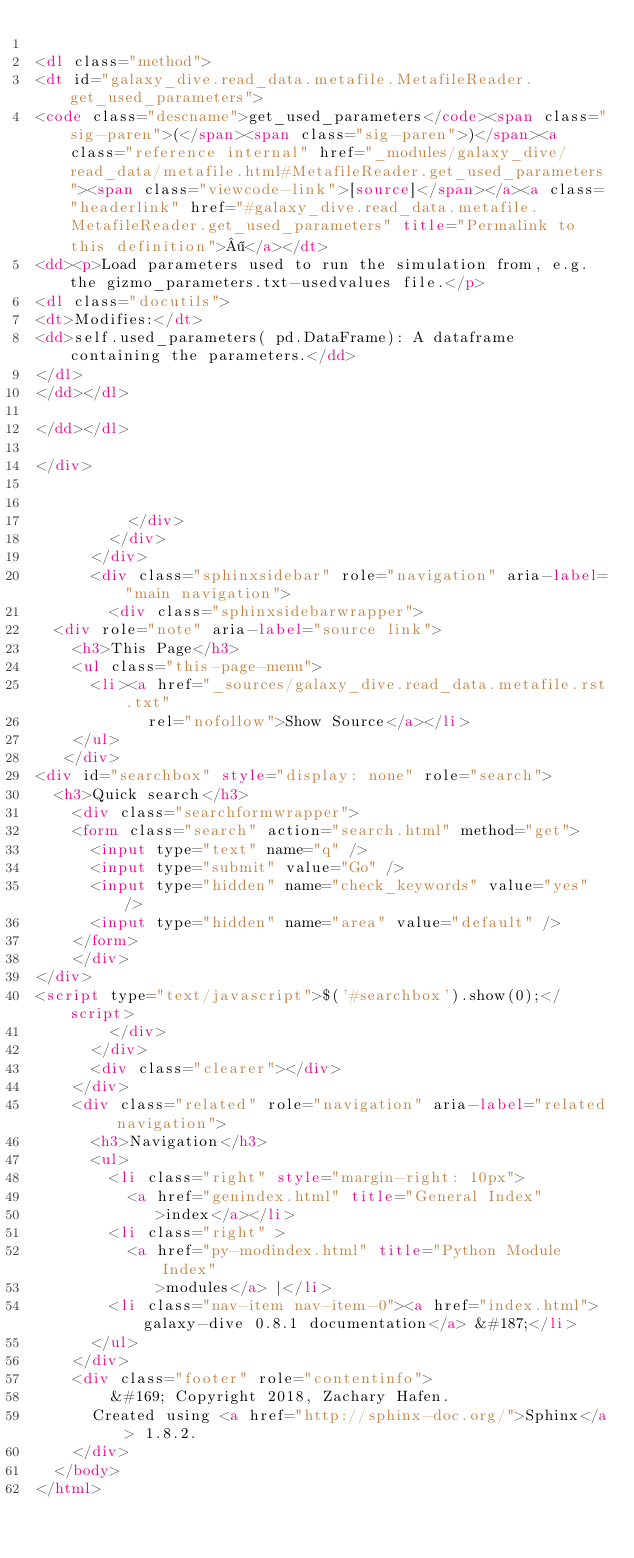Convert code to text. <code><loc_0><loc_0><loc_500><loc_500><_HTML_>
<dl class="method">
<dt id="galaxy_dive.read_data.metafile.MetafileReader.get_used_parameters">
<code class="descname">get_used_parameters</code><span class="sig-paren">(</span><span class="sig-paren">)</span><a class="reference internal" href="_modules/galaxy_dive/read_data/metafile.html#MetafileReader.get_used_parameters"><span class="viewcode-link">[source]</span></a><a class="headerlink" href="#galaxy_dive.read_data.metafile.MetafileReader.get_used_parameters" title="Permalink to this definition">¶</a></dt>
<dd><p>Load parameters used to run the simulation from, e.g. the gizmo_parameters.txt-usedvalues file.</p>
<dl class="docutils">
<dt>Modifies:</dt>
<dd>self.used_parameters( pd.DataFrame): A dataframe containing the parameters.</dd>
</dl>
</dd></dl>

</dd></dl>

</div>


          </div>
        </div>
      </div>
      <div class="sphinxsidebar" role="navigation" aria-label="main navigation">
        <div class="sphinxsidebarwrapper">
  <div role="note" aria-label="source link">
    <h3>This Page</h3>
    <ul class="this-page-menu">
      <li><a href="_sources/galaxy_dive.read_data.metafile.rst.txt"
            rel="nofollow">Show Source</a></li>
    </ul>
   </div>
<div id="searchbox" style="display: none" role="search">
  <h3>Quick search</h3>
    <div class="searchformwrapper">
    <form class="search" action="search.html" method="get">
      <input type="text" name="q" />
      <input type="submit" value="Go" />
      <input type="hidden" name="check_keywords" value="yes" />
      <input type="hidden" name="area" value="default" />
    </form>
    </div>
</div>
<script type="text/javascript">$('#searchbox').show(0);</script>
        </div>
      </div>
      <div class="clearer"></div>
    </div>
    <div class="related" role="navigation" aria-label="related navigation">
      <h3>Navigation</h3>
      <ul>
        <li class="right" style="margin-right: 10px">
          <a href="genindex.html" title="General Index"
             >index</a></li>
        <li class="right" >
          <a href="py-modindex.html" title="Python Module Index"
             >modules</a> |</li>
        <li class="nav-item nav-item-0"><a href="index.html">galaxy-dive 0.8.1 documentation</a> &#187;</li> 
      </ul>
    </div>
    <div class="footer" role="contentinfo">
        &#169; Copyright 2018, Zachary Hafen.
      Created using <a href="http://sphinx-doc.org/">Sphinx</a> 1.8.2.
    </div>
  </body>
</html></code> 